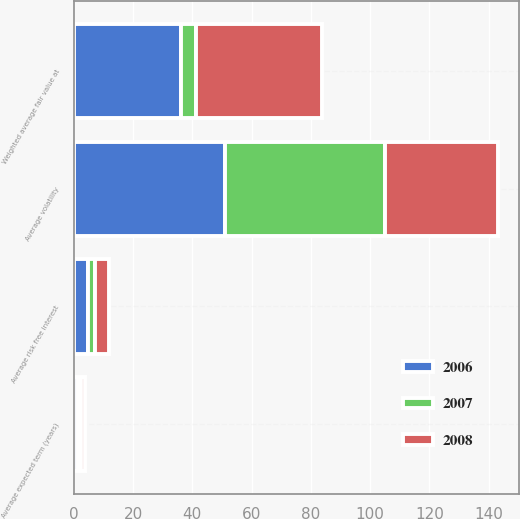<chart> <loc_0><loc_0><loc_500><loc_500><stacked_bar_chart><ecel><fcel>Average risk free interest<fcel>Average expected term (years)<fcel>Average volatility<fcel>Weighted average fair value at<nl><fcel>2007<fcel>2.18<fcel>1.3<fcel>54<fcel>4.89<nl><fcel>2008<fcel>4.89<fcel>1.3<fcel>38<fcel>42.54<nl><fcel>2006<fcel>4.86<fcel>1.3<fcel>51<fcel>36.28<nl></chart> 